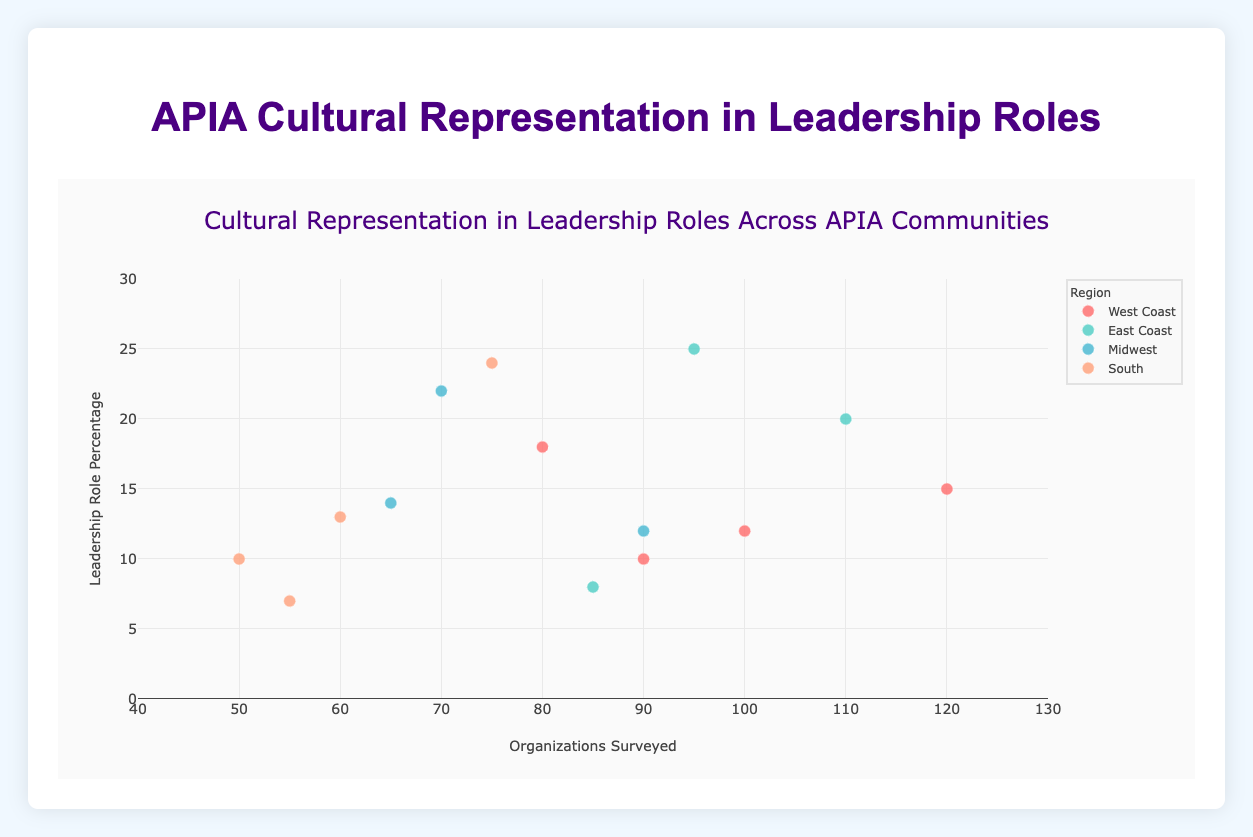How many regions are represented in the plot? The figure has data points color-coded by region. By examining the legend, we can see four regions listed.
Answer: 4 Which community on the East Coast has the highest leadership role percentage and what is that percentage? The figure shows that "Indian American" is the community on the East Coast with the highest percentage of leadership roles, indicated by the highest y-value within the East Coast group.
Answer: Indian American, 25% What's the difference in leadership role percentages between Chinese American communities on the West Coast and the Midwest? Find the points for Chinese American communities in both regions and note their y-values. Subtract the Midwest percentage (12%) from the West Coast percentage (15%).
Answer: 3% Which region has the lowest leadership role percentage for any community, and what is that percentage? Look for the lowest y-value data point across all regions. The point corresponding to "Vietnamese American" in the South has a leadership role percentage of 7%.
Answer: South, 7% Comparing the Japanese American community, in which region is their leadership role percentage higher, and by how much? Identify the points for "Japanese American" in both the West Coast and South regions. The West Coast percentage is 18%, and the South percentage is 10%. Subtract the South percentage from the West Coast percentage.
Answer: West Coast, 8% Which community is represented in all three regions (East Coast, Midwest, and South), and how do their leadership role percentages compare? Identify communities repeated in multiple regions. "Indian American" appears in East Coast, Midwest, and South. Compare the percentages: East Coast (25%), Midwest (22%), and South (24%).
Answer: Indian American, 25%, 22%, 24% What is the total number of organizations surveyed in the Midwest? Sum the x-values for all Midwest points: 90 (Chinese American) + 70 (Indian American) + 65 (Korean American).
Answer: 225 Which region has the greatest variability in leadership role percentages and what is the range? Determine the highest and lowest y-values within each region. The East Coast has percentages ranging from 8% (Vietnamese American) to 25% (Indian American), resulting in the greatest range of 25 - 8 = 17.
Answer: East Coast, 17 